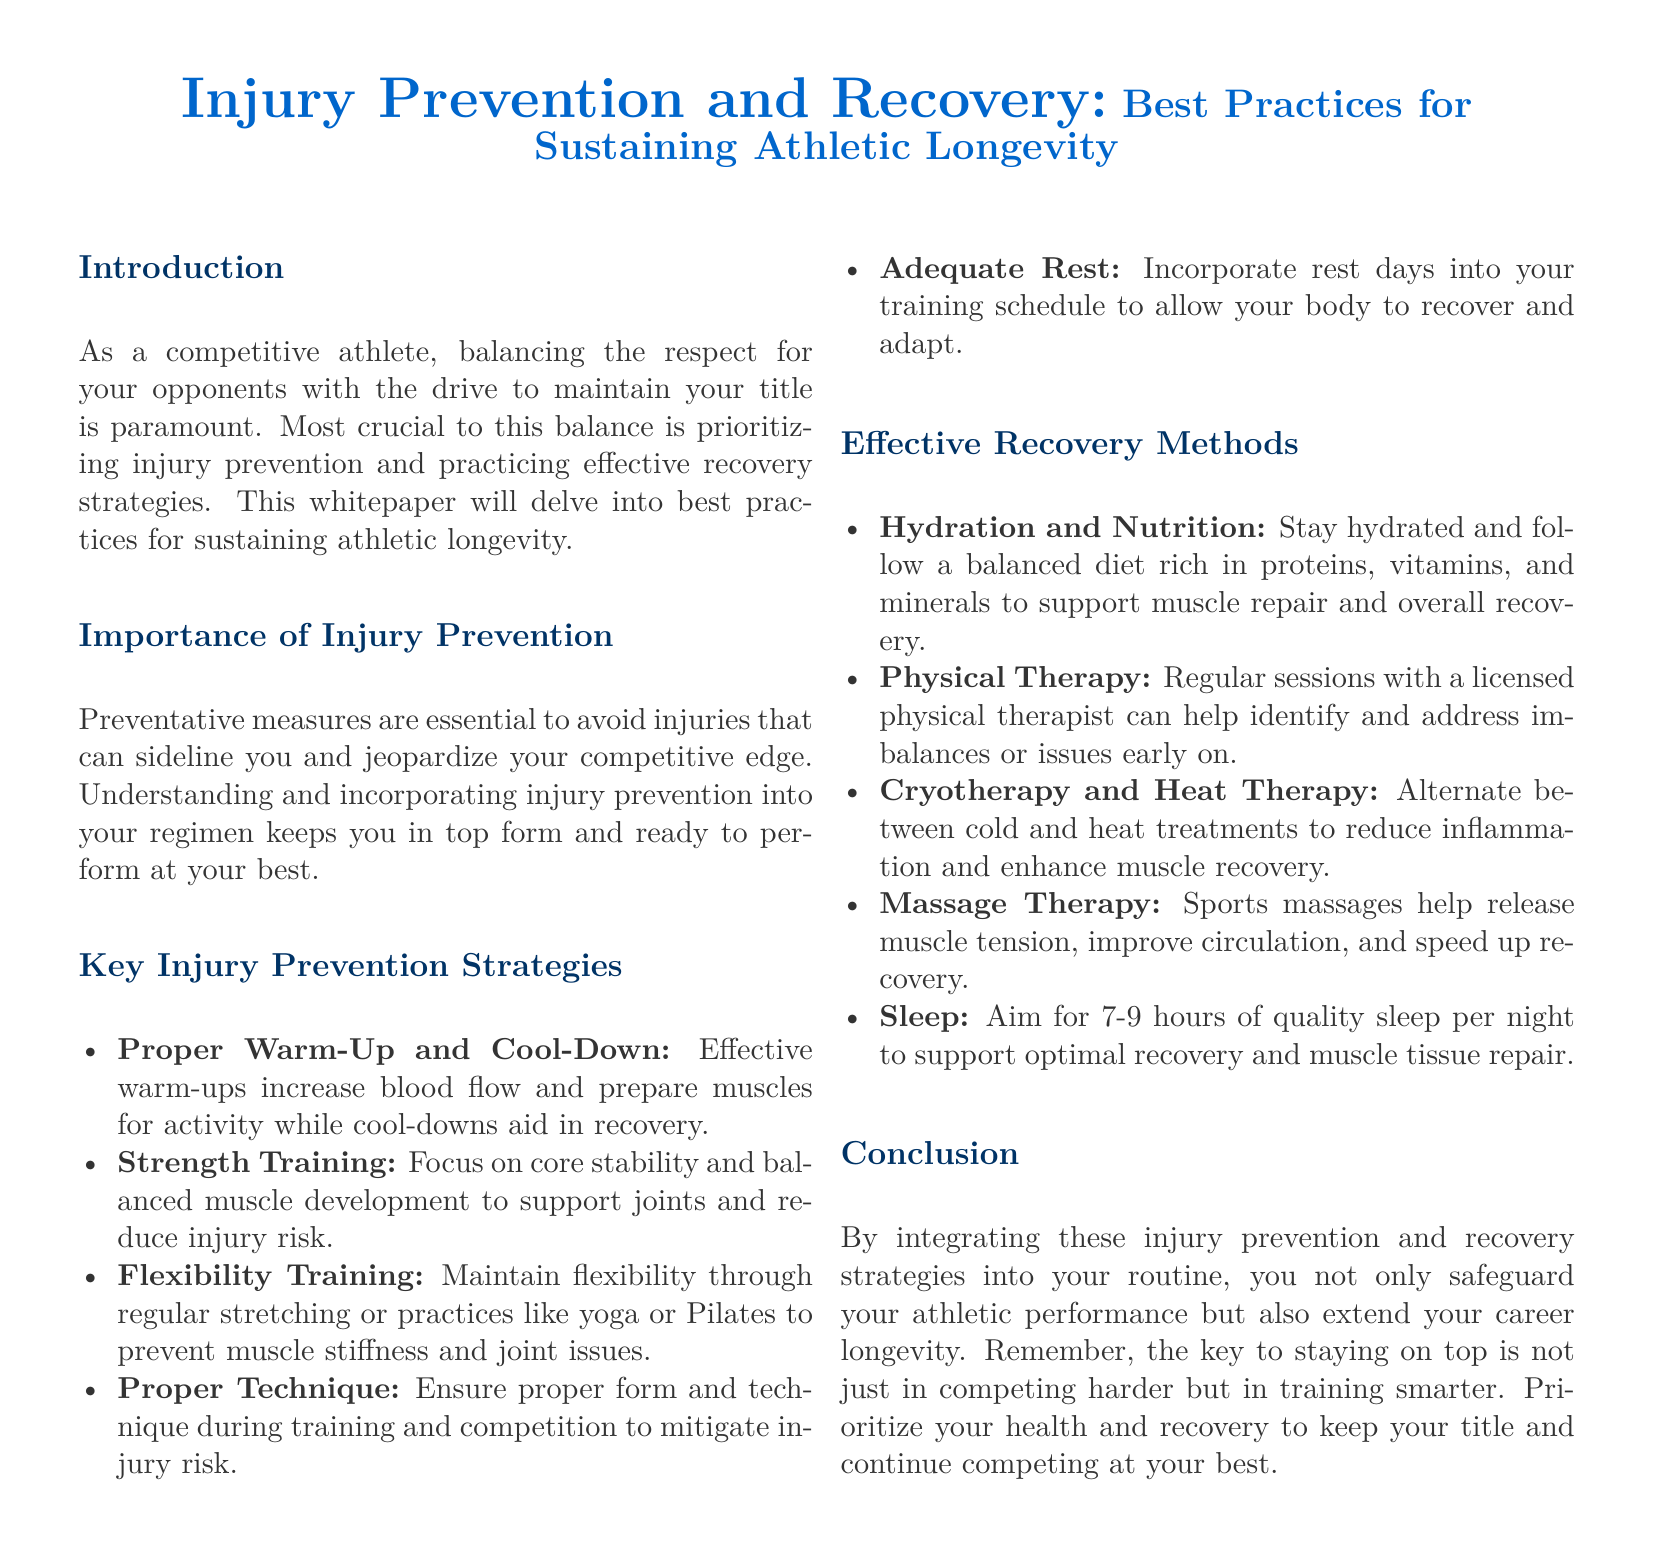What is the title of the whitepaper? The title is presented prominently at the beginning of the document, which highlights the focus on injury prevention and recovery in athletics.
Answer: Injury Prevention and Recovery: Best Practices for Sustaining Athletic Longevity What is one key strategy for injury prevention mentioned? The list outlines several strategies for injury prevention, highlighting the importance of warm-ups, strength training, and more.
Answer: Proper Warm-Up and Cool-Down How many hours of sleep are recommended for optimal recovery? The recommendation for sleep is specified in the recovery methods section, emphasizing its importance.
Answer: 7-9 hours What type of therapy is advised for muscle tension release? The document discusses various recovery methods, including one specifically focused on alleviating muscle tension.
Answer: Massage Therapy What aspect of training does flexibility training aim to maintain? The section on flexibility training discusses its role in preventing muscle stiffness and joint issues.
Answer: Flexibility Why is adequate rest included in the injury prevention strategies? The importance of rest is emphasized for allowing recovery and adaptation during training schedules.
Answer: To allow your body to recover and adapt What is the primary focus of the conclusion? The concluding remarks underscore the necessity of integrating the recommended strategies to protect performance and extend athletic careers.
Answer: To safeguard athletic performance and extend career longevity During which part of the document are cryotherapy and heat therapy discussed? These recovery methods are detailed in a list that describes effective recovery techniques for athletes.
Answer: Effective Recovery Methods What does the introduction mention as paramount for a competitive athlete? The opening section highlights the critical balance competitive athletes must maintain in relation to their opponents and their performance.
Answer: Balancing respect for opponents with the drive to maintain title 